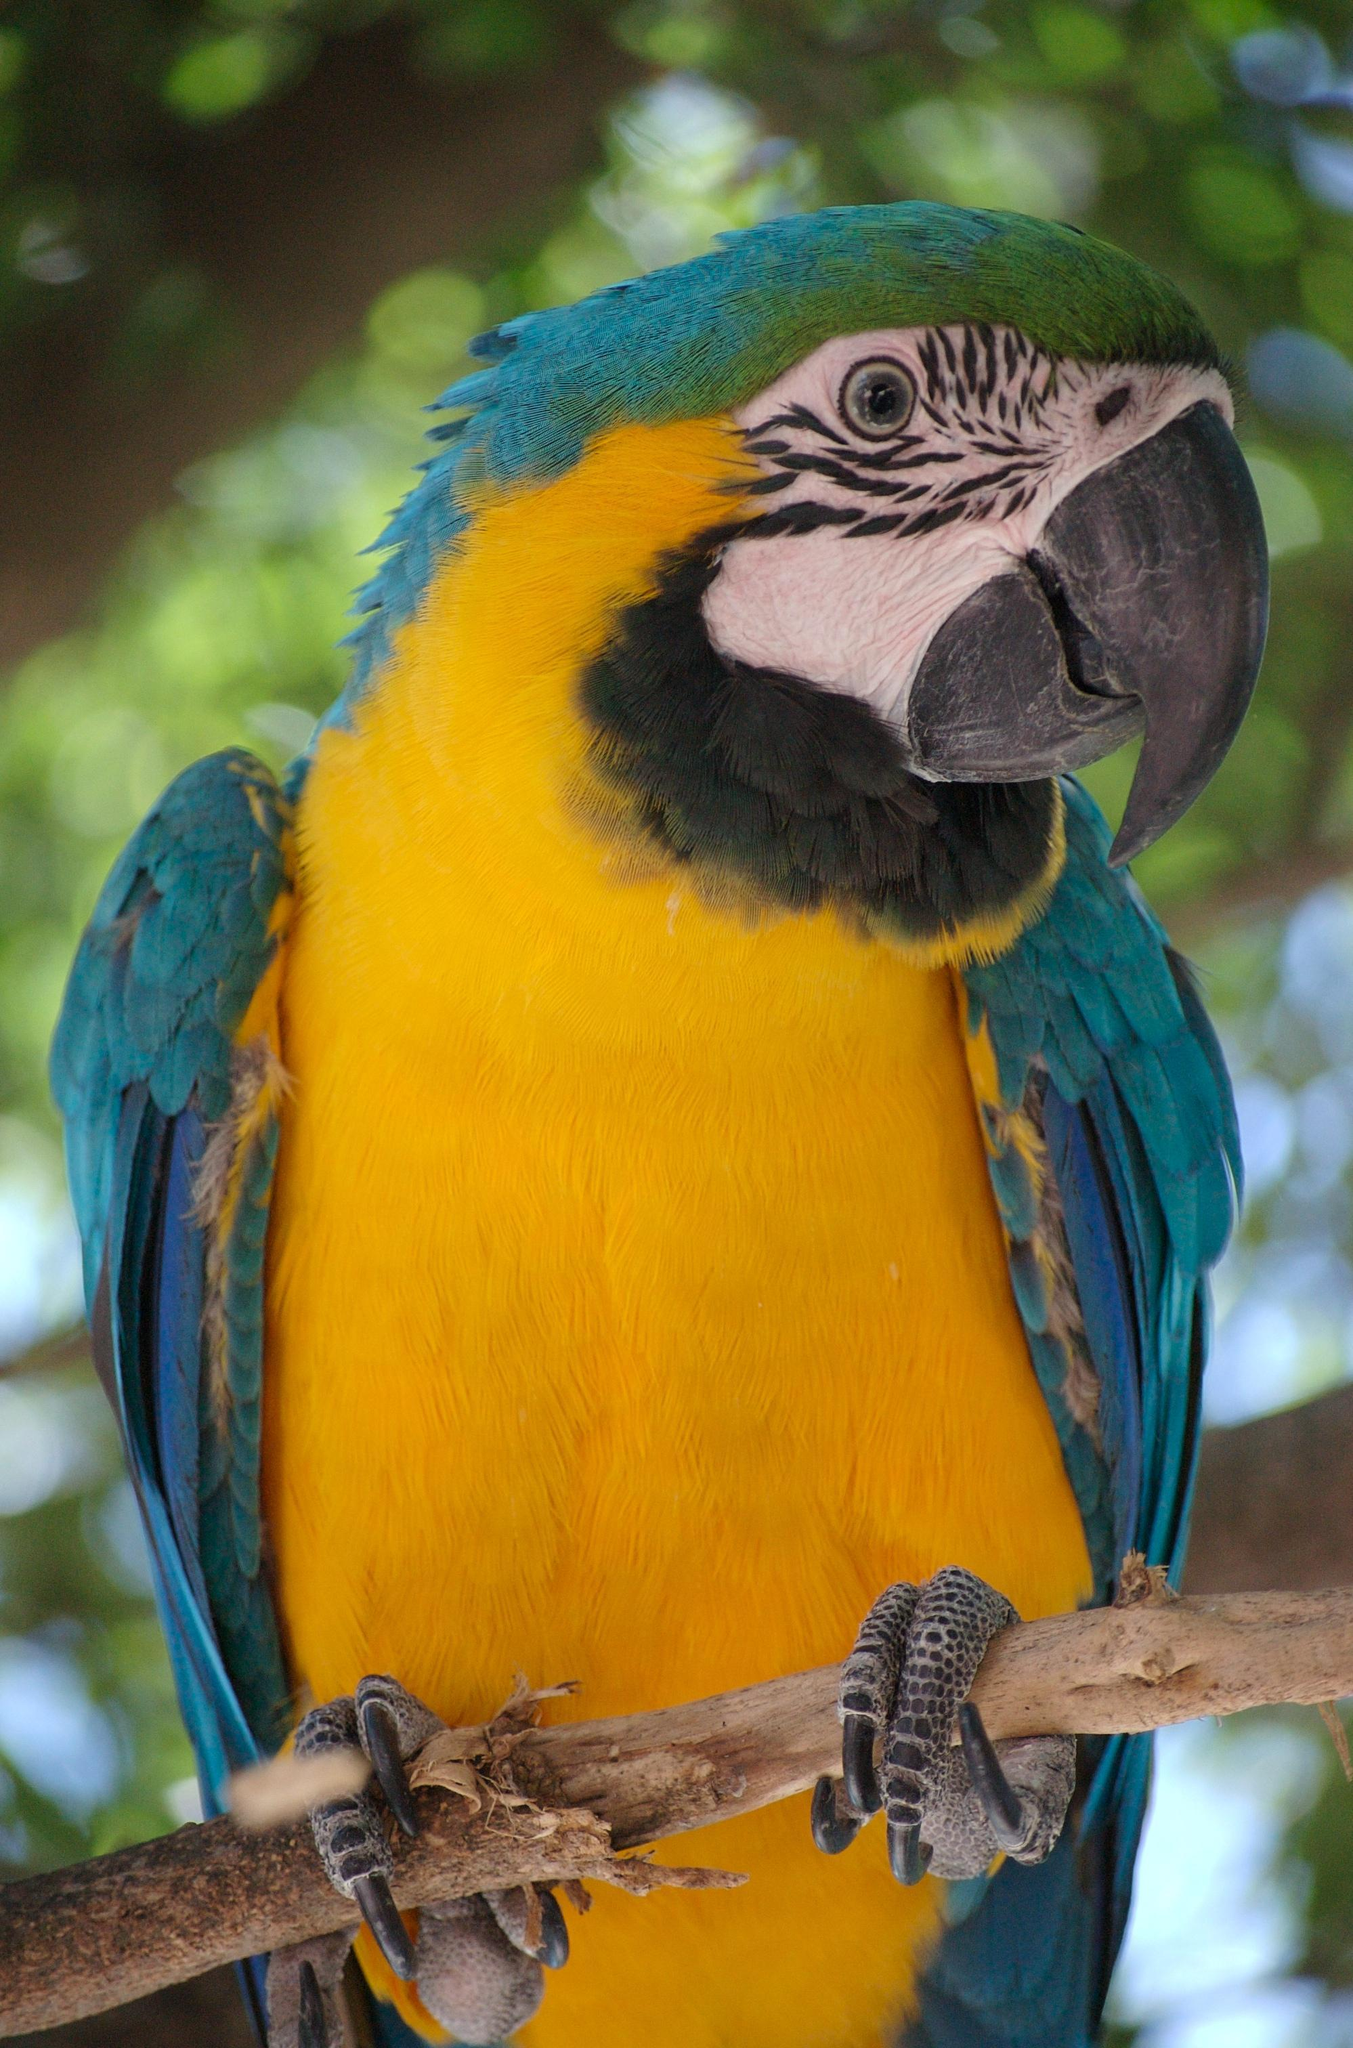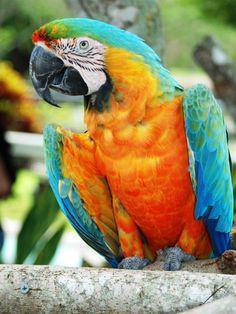The first image is the image on the left, the second image is the image on the right. Evaluate the accuracy of this statement regarding the images: "Two parrots have the same eye design and beak colors.". Is it true? Answer yes or no. Yes. The first image is the image on the left, the second image is the image on the right. Given the left and right images, does the statement "One image shows a parrot that is nearly all yellow-orange in color, without any blue." hold true? Answer yes or no. No. 